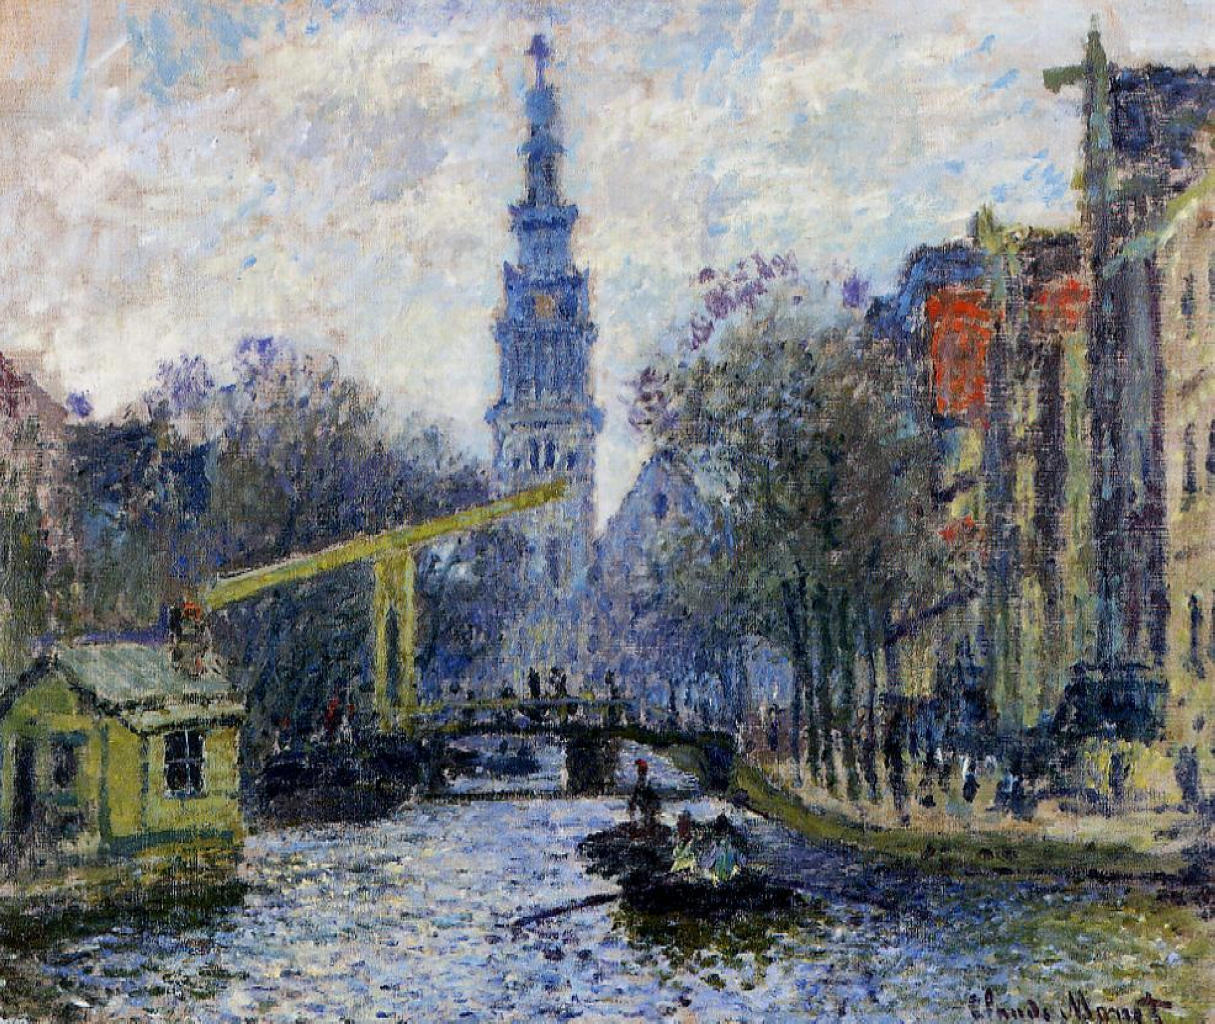What hidden details or elements might go unnoticed at first glance? At first glance, the painting’s overall mood and color harmony capture attention. However, closer inspection reveals several intricate details. Notice the delicate reflections in the canal’s water, suggesting slight ripples and movement. The play of light on the water's surface indicates a keen observation of the natural interplay between light and reflection. The human figures on the bridge and near the canal’s edge, rendered in minimalistic strokes, provide a sense of scale and liveliness to the scene. The varied coloration of the buildings subtly indicates different times of the day and changing weather conditions, capturing the essence of urban life. Additionally, the sky's textured brushstrokes create a dynamic background, emphasizing the transient and ever-changing atmosphere that Monet sought to portray. Can you write a poem inspired by this painting? Upon the canal's mirrored glance,
A city wakes in morning dance.
The bridge, a sunlit golden thread,
Binds dreams and whispers softly said.
Amidst the hues of blue and green,
A tranquil world, a daily scene.
Pale reflections, fleeting, bright,
Capture moments bathed in light.
In Monet's strokes, the city breathes,
Each brush, a soul, on canvas weaves.
Silent waters, stories share,
In colors bold and tender care.
Impression's light, forever stays,
In painted dawns and dusky haze. 